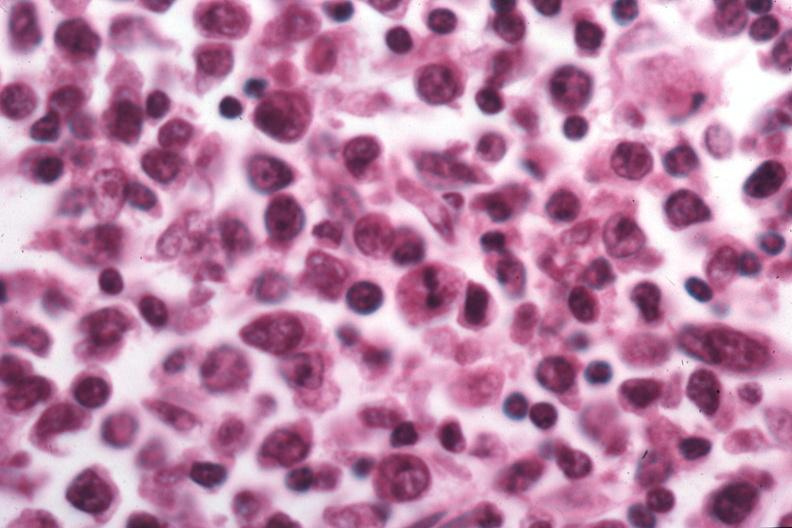s retroperitoneum present?
Answer the question using a single word or phrase. No 